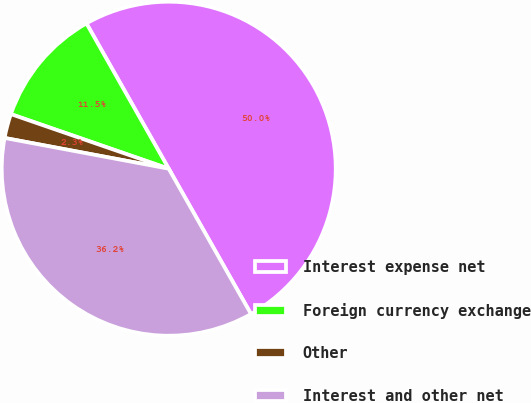Convert chart to OTSL. <chart><loc_0><loc_0><loc_500><loc_500><pie_chart><fcel>Interest expense net<fcel>Foreign currency exchange<fcel>Other<fcel>Interest and other net<nl><fcel>50.0%<fcel>11.5%<fcel>2.35%<fcel>36.15%<nl></chart> 